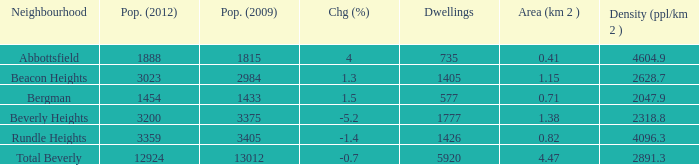What is the density of an area that is 1.38km and has a population more than 12924? 0.0. 